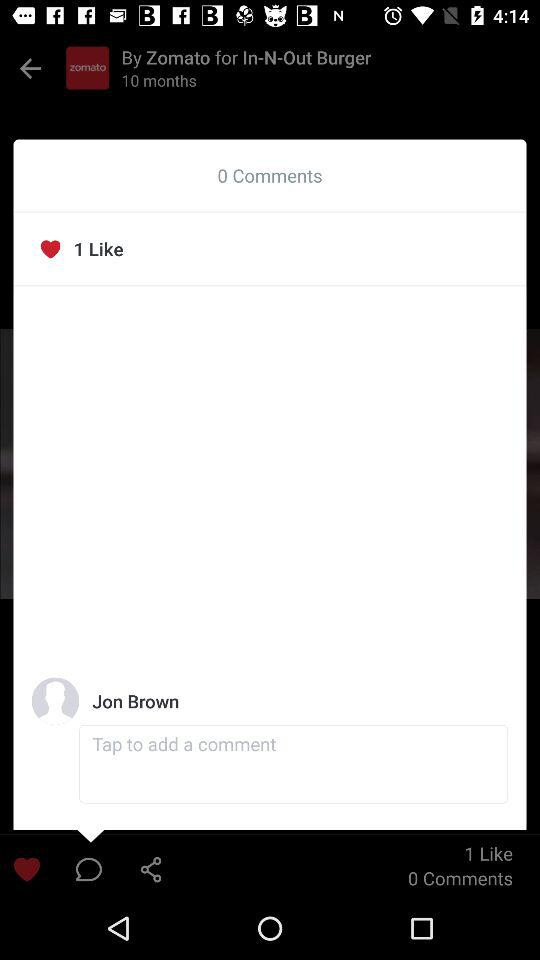How many more likes than comments are there?
Answer the question using a single word or phrase. 1 